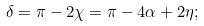<formula> <loc_0><loc_0><loc_500><loc_500>\delta = \pi - 2 \chi = \pi - 4 \alpha + 2 \eta ;</formula> 